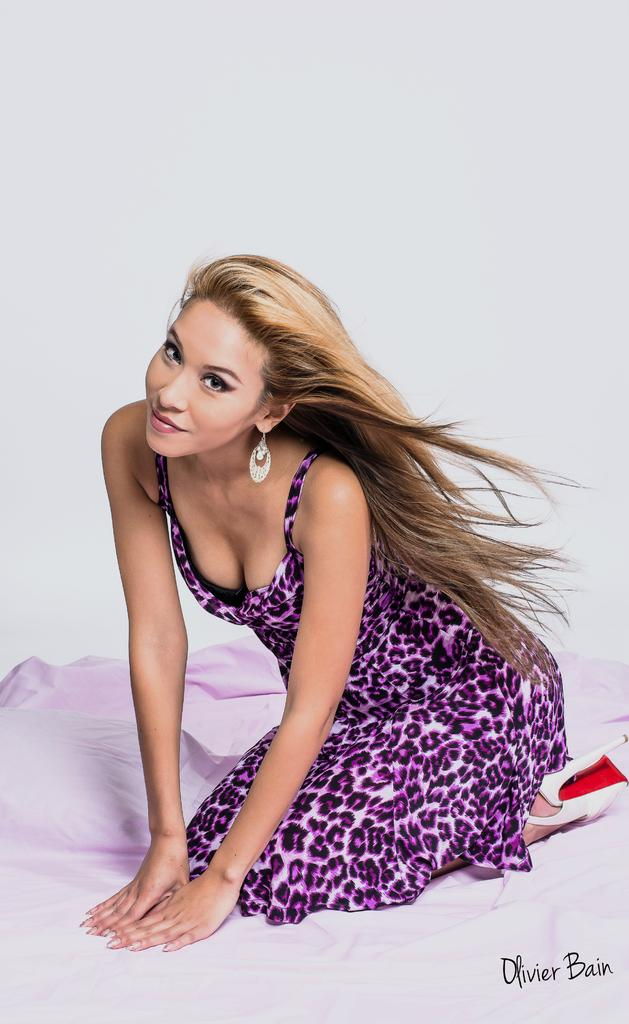Who is the main subject in the image? There is a lady in the image. What position is the lady in? The lady is lying on her knees. What can be seen in the background of the image? There is a cloth in the background of the image. Where is the text located in the image? There is some text in the bottom right corner of the image. How many ducks are visible in the image? There are no ducks present in the image. What type of wash is the lady performing in the image? The image does not depict any washing activity, so it cannot be determined what type of wash the lady is performing. 